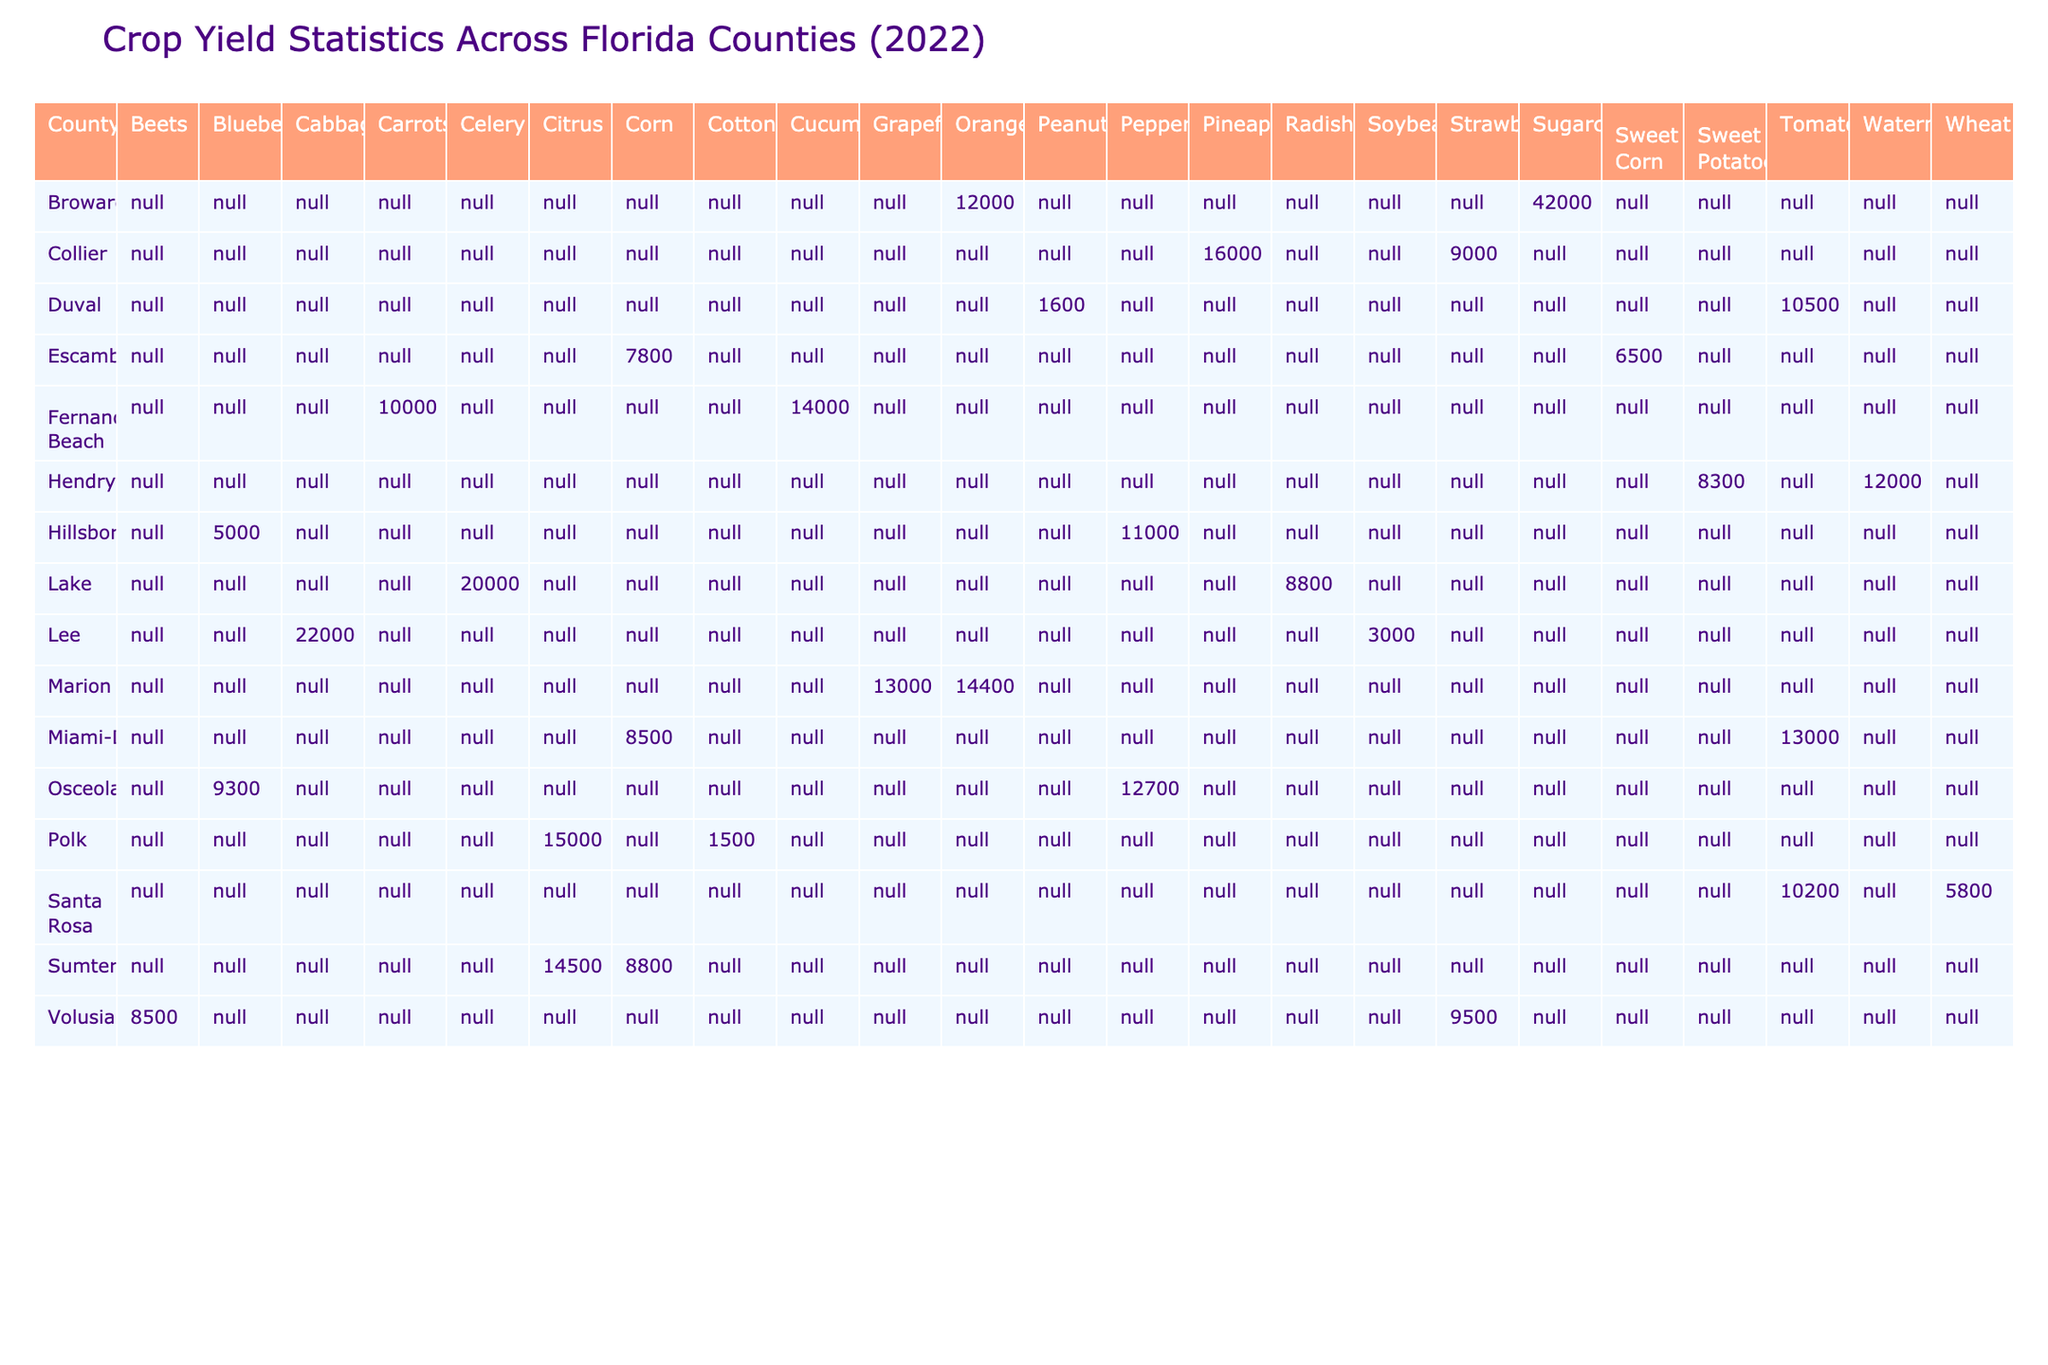What is the highest crop yield reported for tomatoes? The highest crop yield for tomatoes is found by looking at the row with tomatoes in the table. Miami-Dade has a yield of 13,000 lbs per acre, and Santa Rosa has 10,200 lbs per acre. Therefore, the highest yield is 13,000 lbs per acre for Miami-Dade.
Answer: 13,000 lbs per acre Which county has the highest yield for sugarcane? The only county that reports sugarcane yields is Broward, with a yield of 42,000 lbs per acre. Hence, it is also the highest yield for sugarcane.
Answer: Broward, 42,000 lbs per acre What is the average crop yield of citrus across all counties? To calculate the average yield, I find the citrus yields in Polk (15,000), Sumter (14,500), and look for any other counties that might grow citrus. Since only those two counties provide data, I sum 15,000 + 14,500 = 29,500 and divide it by the number of counties (2), which equates to 29,500 / 2 = 14,750.
Answer: 14,750 lbs per acre Which crop yields the lowest amount in Polk County? In Polk County, there are two crops reported: cotton with a yield of 1,500 lbs per acre and citrus with 15,000 lbs per acre. Thus, cotton is the crop with the lowest yield.
Answer: Cotton, 1,500 lbs per acre Are there any counties that reported a crop yield above 20,000 lbs per acre? To answer this, I check each crop yield for all counties. The highest yields present are 22,000 for cabbage in Lee County and 42,000 for sugarcane in Broward. Therefore, there are counties with yields above 20,000 lbs per acre.
Answer: Yes What is the difference in crop yield between the highest and lowest yields for watermelons? To find this, I look for the watermelon yields which appear in Hendry County (12,000 lbs per acre). There is only one county reporting this crop, so the difference is 12,000 - 12,000 = 0.
Answer: 0 lbs per acre Which crop had the highest average yield across all counties listed? I need to calculate the average yields for each crop type. Summing yields for each crop and dividing by the number of instances gives the following: Tomatoes (23,200 / 2 = 11,600), Corn (16,300 / 3 = 5,433.33), Sugarcane (42,000), Strawberries (10,500 / 3 = 3,500), etc. The highest average yield turns out to be for sugarcane at 42,000 lbs per acre.
Answer: Sugarcane, 42,000 lbs per acre How many counties reported yields for sweet potatoes, and what was their yield? I check the table for sweet potatoes and find that only Hendry County reported it with a yield of 8,300 lbs per acre, and since it is the only county, the answer is one.
Answer: One county, Hendry, 8,300 lbs per acre What type of crop has the most counties reporting yields? I determine this by counting how many different counties report a yield for each crop. For example, tomatoes are reported in Miami-Dade and Santa Rosa, corn in Escambia, Sumter, and Miami-Dade, while citrus is reported in Polk and Sumter. The crop with most reporting is citrus, showing in two counties.
Answer: Citrus with 2 counties What was the total yield of blueberries reported across the counties? The yields for blueberries are from Hillsborough (5,000) and Osceola (9,300). I sum these values to get 5,000 + 9,300 = 14,300 lbs per acre.
Answer: 14,300 lbs per acre 